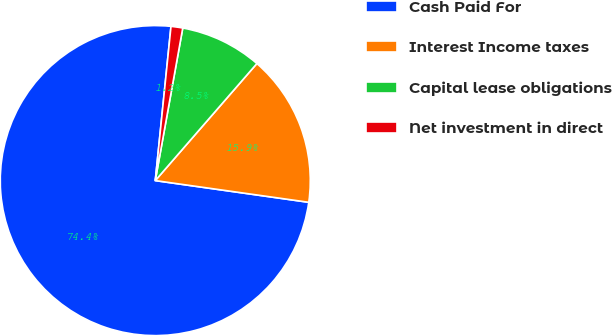<chart> <loc_0><loc_0><loc_500><loc_500><pie_chart><fcel>Cash Paid For<fcel>Interest Income taxes<fcel>Capital lease obligations<fcel>Net investment in direct<nl><fcel>74.38%<fcel>15.86%<fcel>8.54%<fcel>1.22%<nl></chart> 